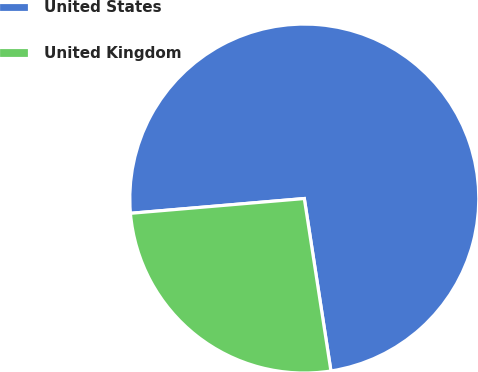Convert chart. <chart><loc_0><loc_0><loc_500><loc_500><pie_chart><fcel>United States<fcel>United Kingdom<nl><fcel>73.91%<fcel>26.09%<nl></chart> 